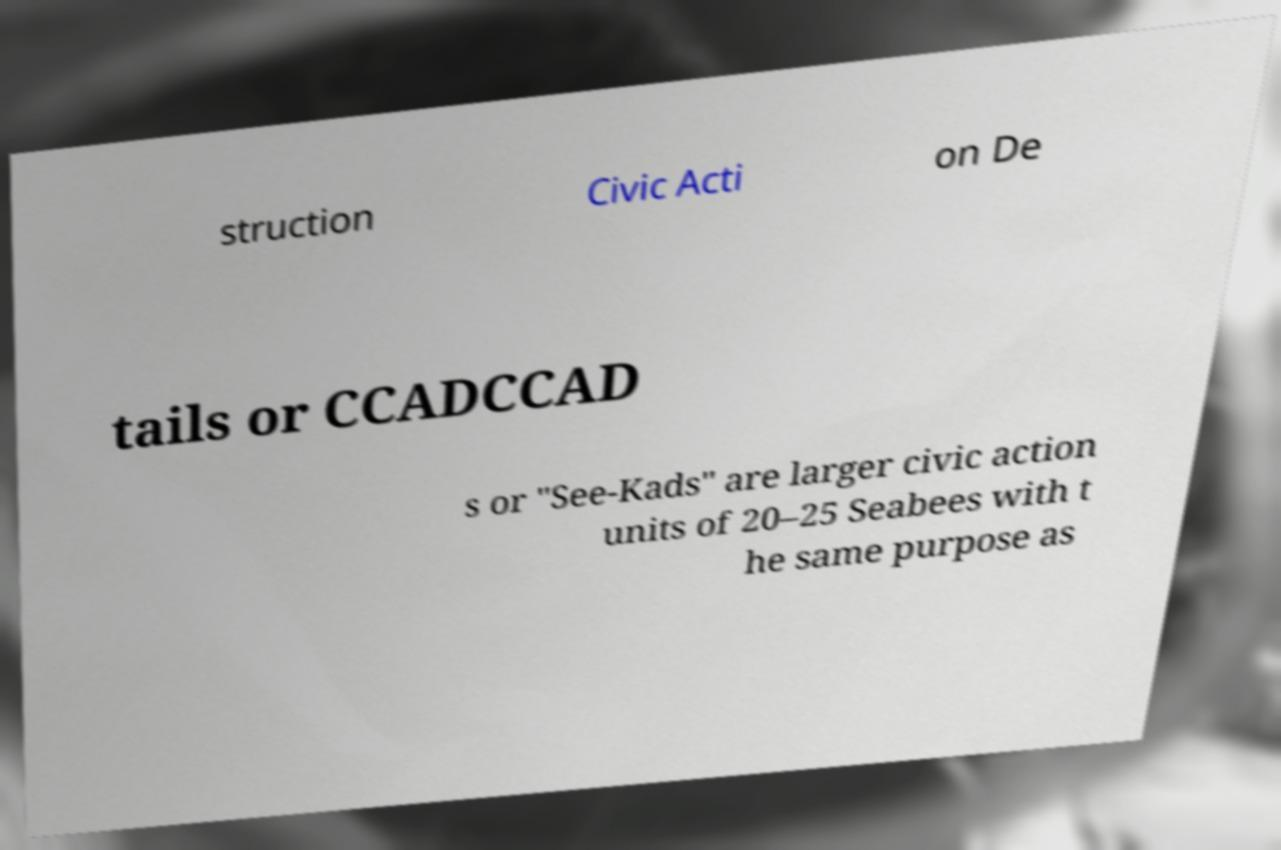I need the written content from this picture converted into text. Can you do that? struction Civic Acti on De tails or CCADCCAD s or "See-Kads" are larger civic action units of 20–25 Seabees with t he same purpose as 